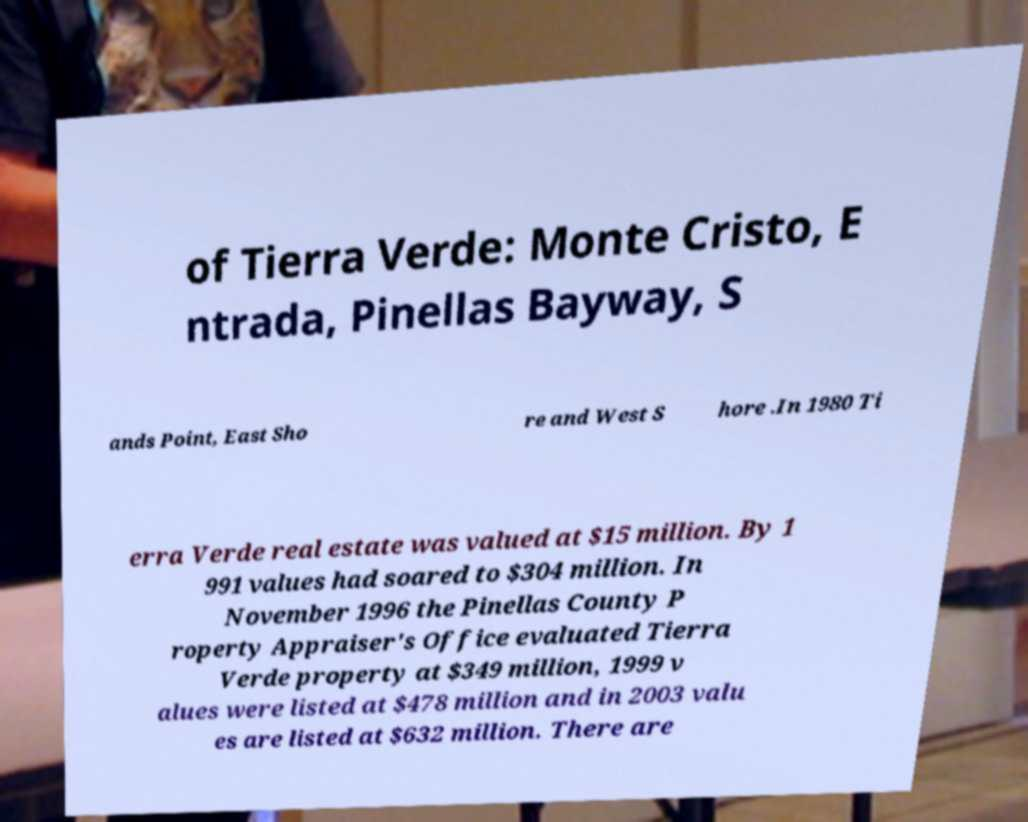Can you read and provide the text displayed in the image?This photo seems to have some interesting text. Can you extract and type it out for me? of Tierra Verde: Monte Cristo, E ntrada, Pinellas Bayway, S ands Point, East Sho re and West S hore .In 1980 Ti erra Verde real estate was valued at $15 million. By 1 991 values had soared to $304 million. In November 1996 the Pinellas County P roperty Appraiser's Office evaluated Tierra Verde property at $349 million, 1999 v alues were listed at $478 million and in 2003 valu es are listed at $632 million. There are 